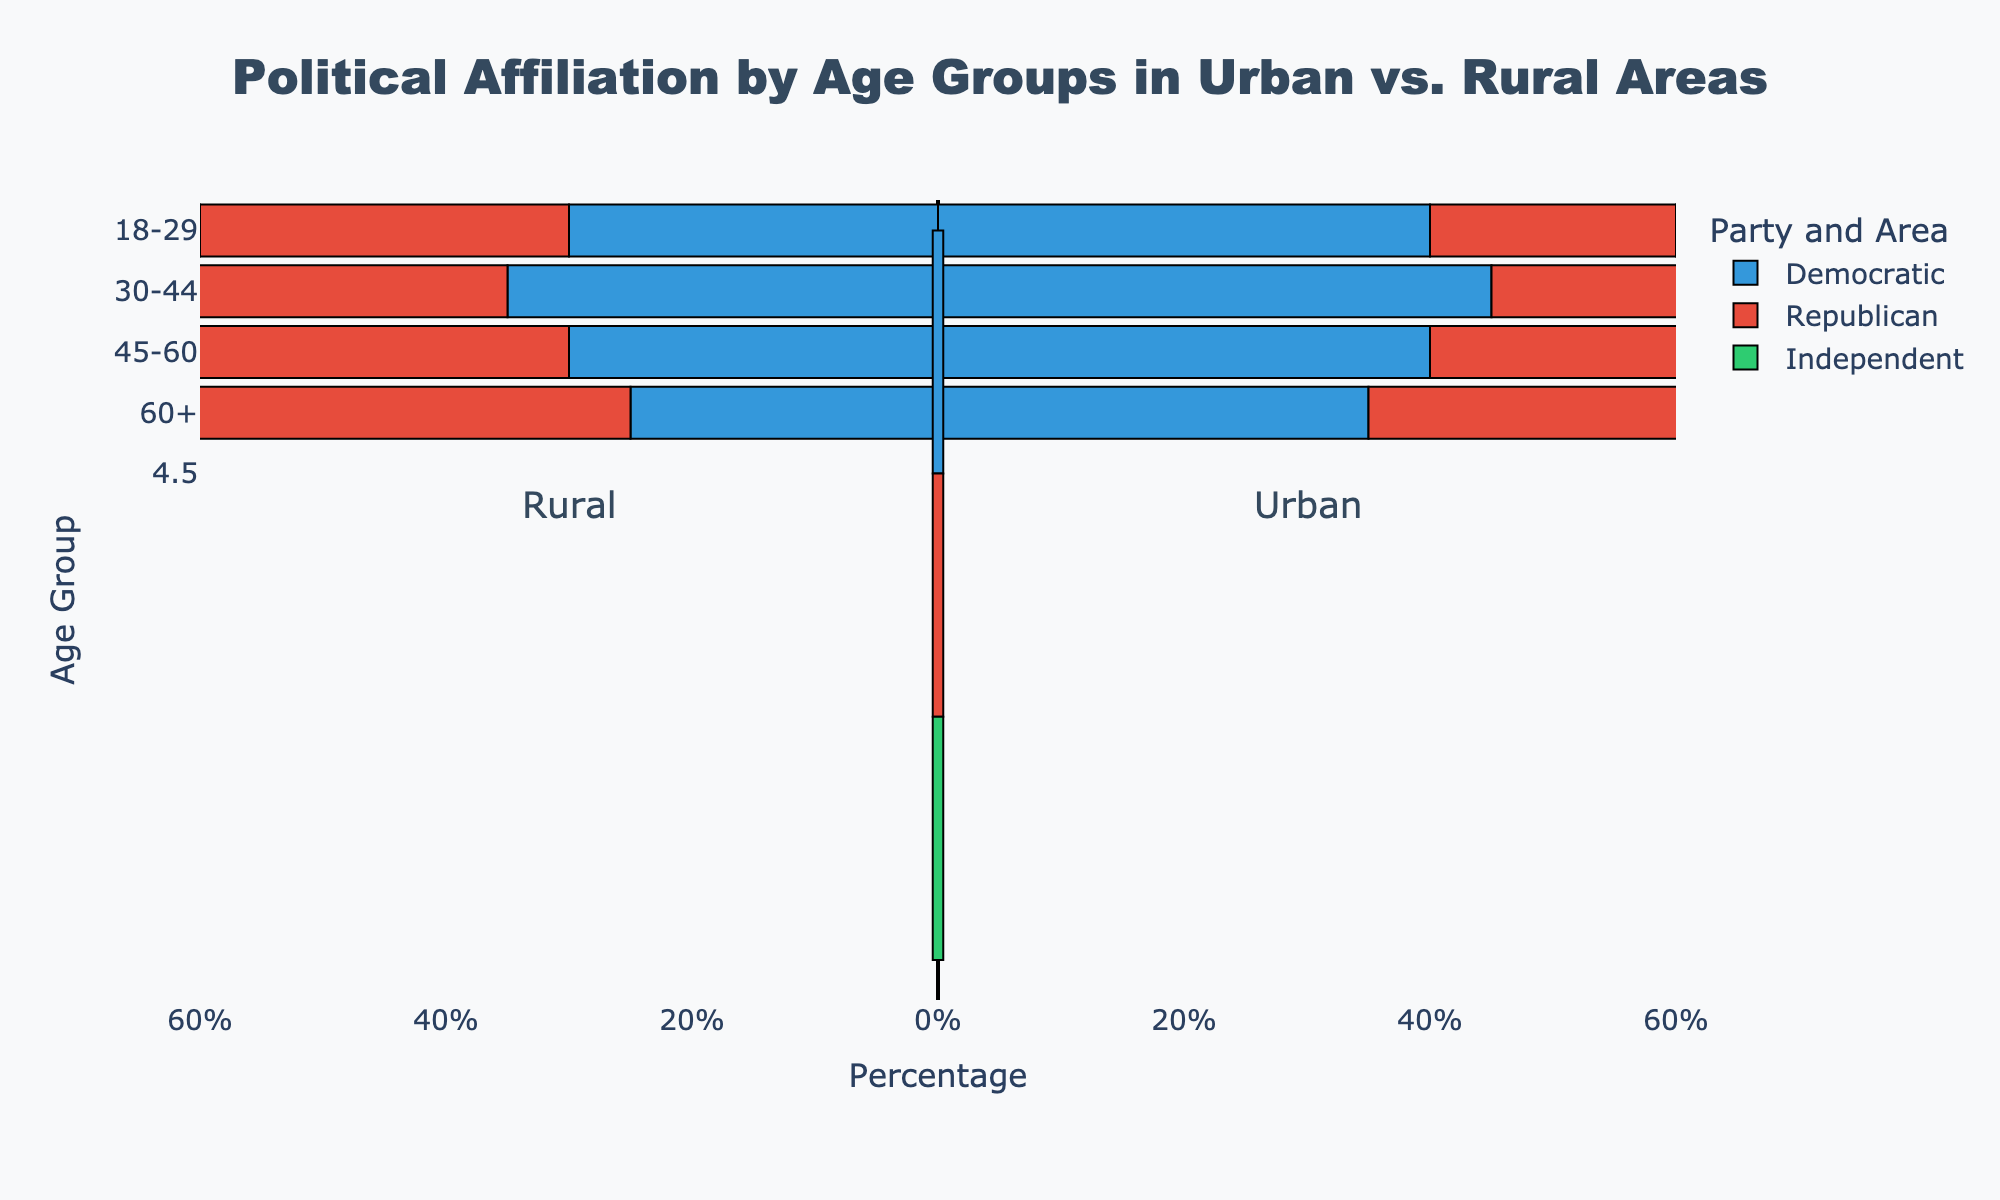Which age group has the highest percentage of Democrats in urban areas? Look for the blue bar (representing Democrats) in urban areas and compare percentages across age groups. The highest value is in the 30-44 age group.
Answer: 30-44 Which area has a higher percentage of Republicans for the 45-60 age group? Compare the red bars (representing Republicans) for the 45-60 age group between urban and rural areas. Rural areas have a higher percentage.
Answer: Rural What is the percentage difference between rural and urban Independents in the 30-44 age group? Identify the green bars (representing Independents) for the 30-44 age group in both areas and subtract the rural percentage from the urban percentage. It's 30% - 30% = 0%.
Answer: 0% Which age group in rural areas has the smallest percentage of Independents? Look for the green bars (representing Independents) in rural areas and identify the smallest value. The 60+ age group has the smallest percentage.
Answer: 60+ Is the percentage of Republicans greater in urban or rural areas for the 60+ age group? Compare the red bars (representing Republicans) for the 60+ age group in urban and rural areas. The rural area has a higher percentage.
Answer: Rural In urban areas, which age group has the smallest percentage of Independents? Look for the green bars (representing Independents) in urban areas and identify the smallest value. The 45-60 age group has the smallest percentage.
Answer: 45-60 Compare the percentage of Democrats and Republicans in the 18-29 age group in rural areas. Which is higher? Look at the blue and red bars (representing Democrats and Republicans) for the 18-29 age group in rural areas. The percentages are equal at 30%.
Answer: Equal How do the percentages of Democrats in urban areas change across age groups? Observe the blue bars (representing Democrats) in urban areas and note the changes across different age groups. The percentages are 40% for 18-29, 45% for 30-44, 40% for 45-60, and 35% for 60+.
Answer: Decrease Which party has the highest percentage in rural areas for the 45-60 age group? Examine the bars for the 45-60 age group in rural areas and identify the highest value. The highest value is the red bar representing Republicans.
Answer: Republican 